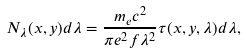Convert formula to latex. <formula><loc_0><loc_0><loc_500><loc_500>N _ { \lambda } ( x , y ) d \lambda = \frac { m _ { e } c ^ { 2 } } { \pi e ^ { 2 } f \lambda ^ { 2 } } \tau ( x , y , \lambda ) d \lambda ,</formula> 